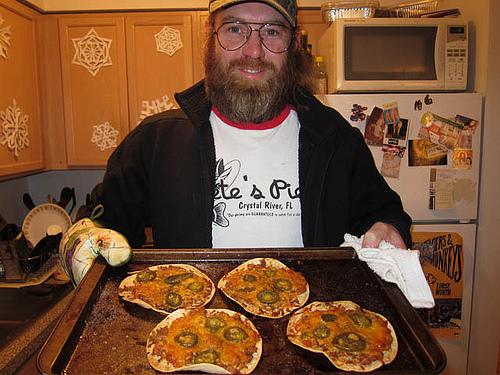Are these pancakes?
Be succinct. No. Are these pizza cooked?
Short answer required. Yes. Is this Pizza Hut?
Give a very brief answer. No. 